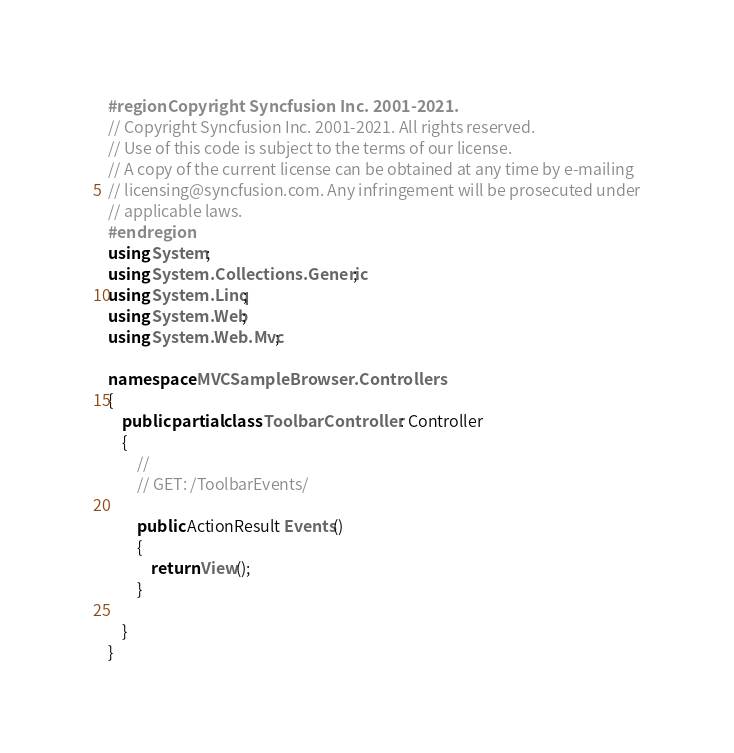Convert code to text. <code><loc_0><loc_0><loc_500><loc_500><_C#_>#region Copyright Syncfusion Inc. 2001-2021.
// Copyright Syncfusion Inc. 2001-2021. All rights reserved.
// Use of this code is subject to the terms of our license.
// A copy of the current license can be obtained at any time by e-mailing
// licensing@syncfusion.com. Any infringement will be prosecuted under
// applicable laws. 
#endregion
using System;
using System.Collections.Generic;
using System.Linq;
using System.Web;
using System.Web.Mvc;

namespace MVCSampleBrowser.Controllers
{
    public partial class ToolbarController : Controller
    {
        //
        // GET: /ToolbarEvents/

        public ActionResult Events()
        {
            return View();
        }

    }
}
</code> 